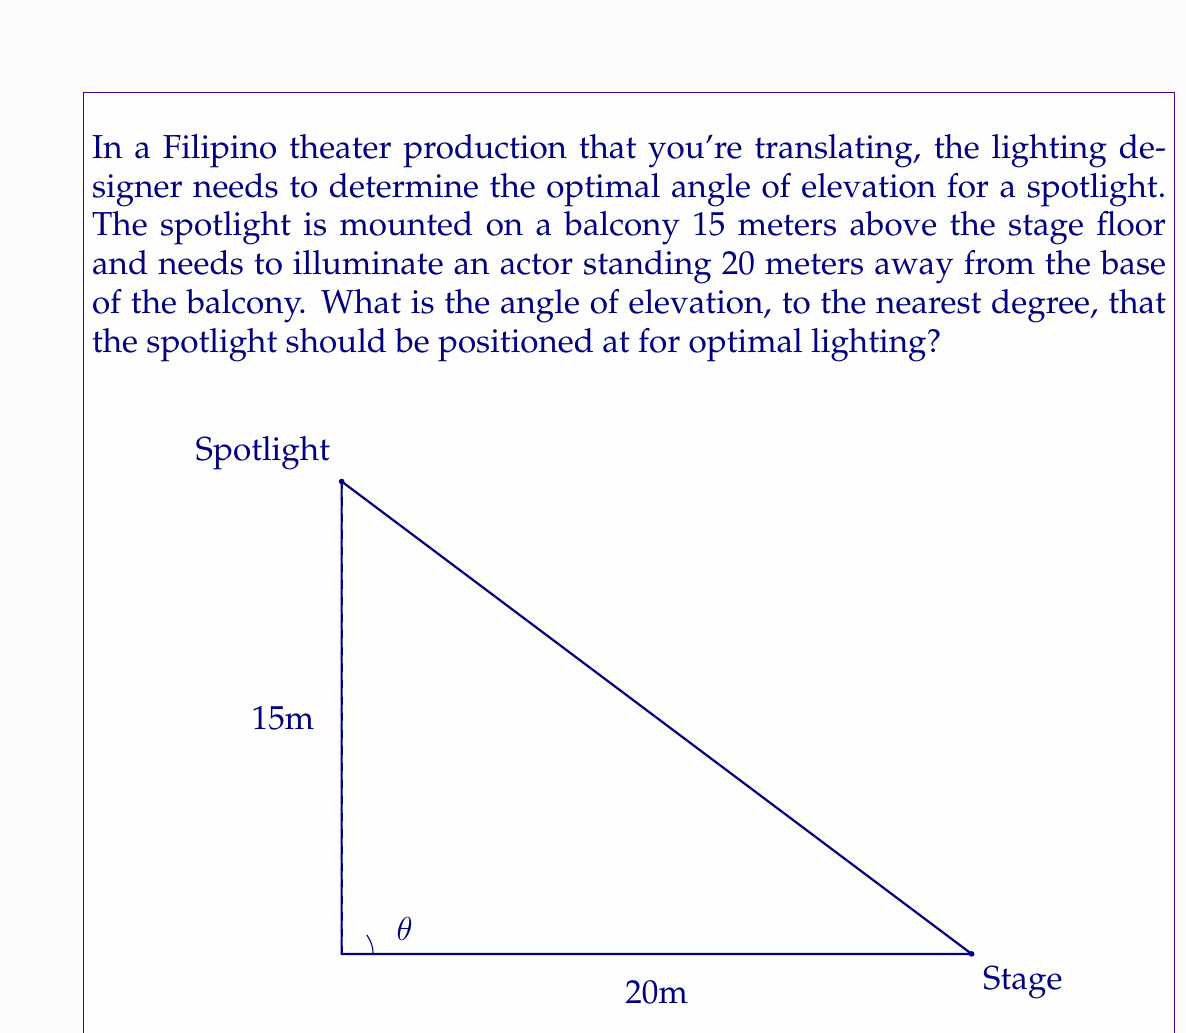Can you answer this question? To solve this problem, we can use trigonometry, specifically the tangent function. Let's break it down step-by-step:

1) In the right triangle formed by the spotlight, the actor, and the base of the balcony:
   - The adjacent side is the horizontal distance from the balcony to the actor (20 meters)
   - The opposite side is the height of the spotlight (15 meters)
   - The angle we're looking for is the angle of elevation, let's call it $\theta$

2) The tangent of an angle in a right triangle is the ratio of the opposite side to the adjacent side:

   $$\tan(\theta) = \frac{\text{opposite}}{\text{adjacent}} = \frac{15}{20}$$

3) To find $\theta$, we need to use the inverse tangent (arctan or $\tan^{-1}$) function:

   $$\theta = \tan^{-1}\left(\frac{15}{20}\right)$$

4) Using a calculator or computer:

   $$\theta = \tan^{-1}(0.75) \approx 36.87^\circ$$

5) Rounding to the nearest degree:

   $$\theta \approx 37^\circ$$

Therefore, the spotlight should be positioned at an angle of elevation of approximately 37 degrees for optimal lighting of the actor on stage.
Answer: $37^\circ$ 